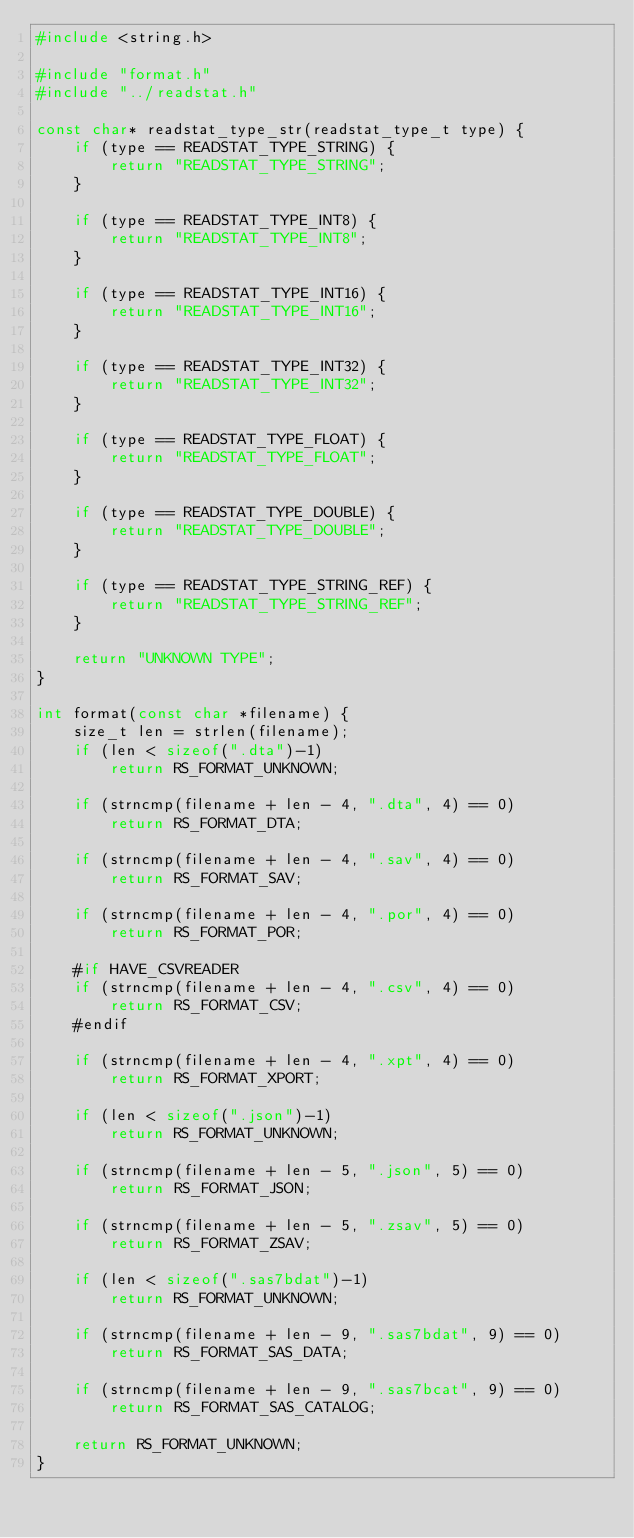Convert code to text. <code><loc_0><loc_0><loc_500><loc_500><_C_>#include <string.h>

#include "format.h"
#include "../readstat.h"

const char* readstat_type_str(readstat_type_t type) {
    if (type == READSTAT_TYPE_STRING) {
        return "READSTAT_TYPE_STRING";
    }
    
    if (type == READSTAT_TYPE_INT8) {
        return "READSTAT_TYPE_INT8";
    }

    if (type == READSTAT_TYPE_INT16) {
        return "READSTAT_TYPE_INT16";
    }

    if (type == READSTAT_TYPE_INT32) {
        return "READSTAT_TYPE_INT32";
    }

    if (type == READSTAT_TYPE_FLOAT) {
        return "READSTAT_TYPE_FLOAT";
    }

    if (type == READSTAT_TYPE_DOUBLE) {
        return "READSTAT_TYPE_DOUBLE";
    }

    if (type == READSTAT_TYPE_STRING_REF) {
        return "READSTAT_TYPE_STRING_REF";
    }

    return "UNKNOWN TYPE";
} 

int format(const char *filename) {
    size_t len = strlen(filename);
    if (len < sizeof(".dta")-1)
        return RS_FORMAT_UNKNOWN;

    if (strncmp(filename + len - 4, ".dta", 4) == 0)
        return RS_FORMAT_DTA;

    if (strncmp(filename + len - 4, ".sav", 4) == 0)
        return RS_FORMAT_SAV;

    if (strncmp(filename + len - 4, ".por", 4) == 0)
        return RS_FORMAT_POR;

    #if HAVE_CSVREADER
    if (strncmp(filename + len - 4, ".csv", 4) == 0)
        return RS_FORMAT_CSV;
    #endif

    if (strncmp(filename + len - 4, ".xpt", 4) == 0)
        return RS_FORMAT_XPORT;

    if (len < sizeof(".json")-1)
        return RS_FORMAT_UNKNOWN;
    
    if (strncmp(filename + len - 5, ".json", 5) == 0)
        return RS_FORMAT_JSON;

    if (strncmp(filename + len - 5, ".zsav", 5) == 0)
        return RS_FORMAT_ZSAV;

    if (len < sizeof(".sas7bdat")-1)
        return RS_FORMAT_UNKNOWN;

    if (strncmp(filename + len - 9, ".sas7bdat", 9) == 0)
        return RS_FORMAT_SAS_DATA;

    if (strncmp(filename + len - 9, ".sas7bcat", 9) == 0)
        return RS_FORMAT_SAS_CATALOG;

    return RS_FORMAT_UNKNOWN;
}
</code> 